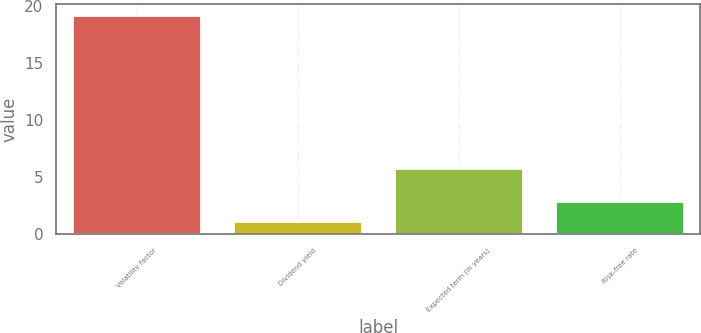Convert chart. <chart><loc_0><loc_0><loc_500><loc_500><bar_chart><fcel>Volatility factor<fcel>Dividend yield<fcel>Expected term (in years)<fcel>Risk-free rate<nl><fcel>19.2<fcel>1.1<fcel>5.78<fcel>2.91<nl></chart> 